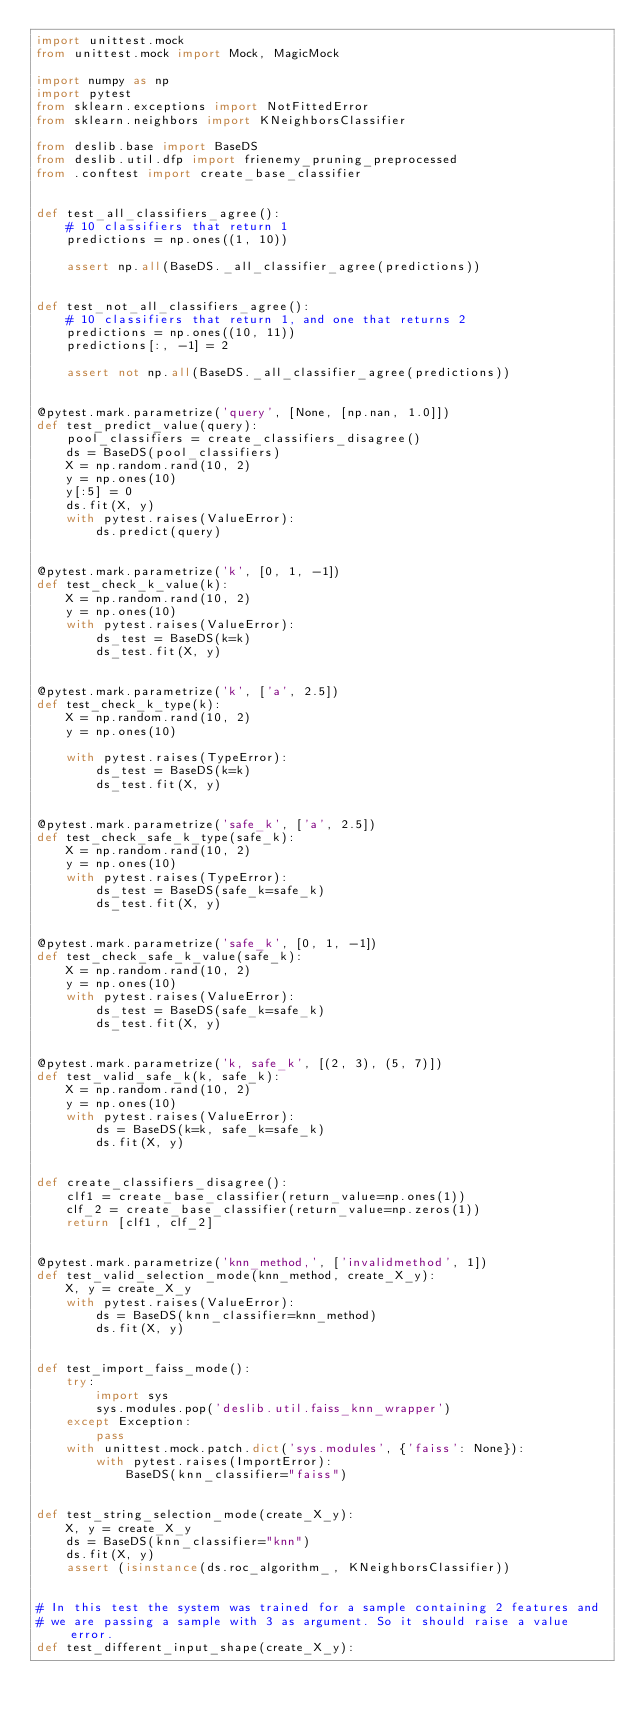Convert code to text. <code><loc_0><loc_0><loc_500><loc_500><_Python_>import unittest.mock
from unittest.mock import Mock, MagicMock

import numpy as np
import pytest
from sklearn.exceptions import NotFittedError
from sklearn.neighbors import KNeighborsClassifier

from deslib.base import BaseDS
from deslib.util.dfp import frienemy_pruning_preprocessed
from .conftest import create_base_classifier


def test_all_classifiers_agree():
    # 10 classifiers that return 1
    predictions = np.ones((1, 10))

    assert np.all(BaseDS._all_classifier_agree(predictions))


def test_not_all_classifiers_agree():
    # 10 classifiers that return 1, and one that returns 2
    predictions = np.ones((10, 11))
    predictions[:, -1] = 2

    assert not np.all(BaseDS._all_classifier_agree(predictions))


@pytest.mark.parametrize('query', [None, [np.nan, 1.0]])
def test_predict_value(query):
    pool_classifiers = create_classifiers_disagree()
    ds = BaseDS(pool_classifiers)
    X = np.random.rand(10, 2)
    y = np.ones(10)
    y[:5] = 0
    ds.fit(X, y)
    with pytest.raises(ValueError):
        ds.predict(query)


@pytest.mark.parametrize('k', [0, 1, -1])
def test_check_k_value(k):
    X = np.random.rand(10, 2)
    y = np.ones(10)
    with pytest.raises(ValueError):
        ds_test = BaseDS(k=k)
        ds_test.fit(X, y)


@pytest.mark.parametrize('k', ['a', 2.5])
def test_check_k_type(k):
    X = np.random.rand(10, 2)
    y = np.ones(10)

    with pytest.raises(TypeError):
        ds_test = BaseDS(k=k)
        ds_test.fit(X, y)


@pytest.mark.parametrize('safe_k', ['a', 2.5])
def test_check_safe_k_type(safe_k):
    X = np.random.rand(10, 2)
    y = np.ones(10)
    with pytest.raises(TypeError):
        ds_test = BaseDS(safe_k=safe_k)
        ds_test.fit(X, y)


@pytest.mark.parametrize('safe_k', [0, 1, -1])
def test_check_safe_k_value(safe_k):
    X = np.random.rand(10, 2)
    y = np.ones(10)
    with pytest.raises(ValueError):
        ds_test = BaseDS(safe_k=safe_k)
        ds_test.fit(X, y)


@pytest.mark.parametrize('k, safe_k', [(2, 3), (5, 7)])
def test_valid_safe_k(k, safe_k):
    X = np.random.rand(10, 2)
    y = np.ones(10)
    with pytest.raises(ValueError):
        ds = BaseDS(k=k, safe_k=safe_k)
        ds.fit(X, y)


def create_classifiers_disagree():
    clf1 = create_base_classifier(return_value=np.ones(1))
    clf_2 = create_base_classifier(return_value=np.zeros(1))
    return [clf1, clf_2]


@pytest.mark.parametrize('knn_method,', ['invalidmethod', 1])
def test_valid_selection_mode(knn_method, create_X_y):
    X, y = create_X_y
    with pytest.raises(ValueError):
        ds = BaseDS(knn_classifier=knn_method)
        ds.fit(X, y)


def test_import_faiss_mode():
    try:
        import sys
        sys.modules.pop('deslib.util.faiss_knn_wrapper')
    except Exception:
        pass
    with unittest.mock.patch.dict('sys.modules', {'faiss': None}):
        with pytest.raises(ImportError):
            BaseDS(knn_classifier="faiss")


def test_string_selection_mode(create_X_y):
    X, y = create_X_y
    ds = BaseDS(knn_classifier="knn")
    ds.fit(X, y)
    assert (isinstance(ds.roc_algorithm_, KNeighborsClassifier))


# In this test the system was trained for a sample containing 2 features and
# we are passing a sample with 3 as argument. So it should raise a value error.
def test_different_input_shape(create_X_y):</code> 